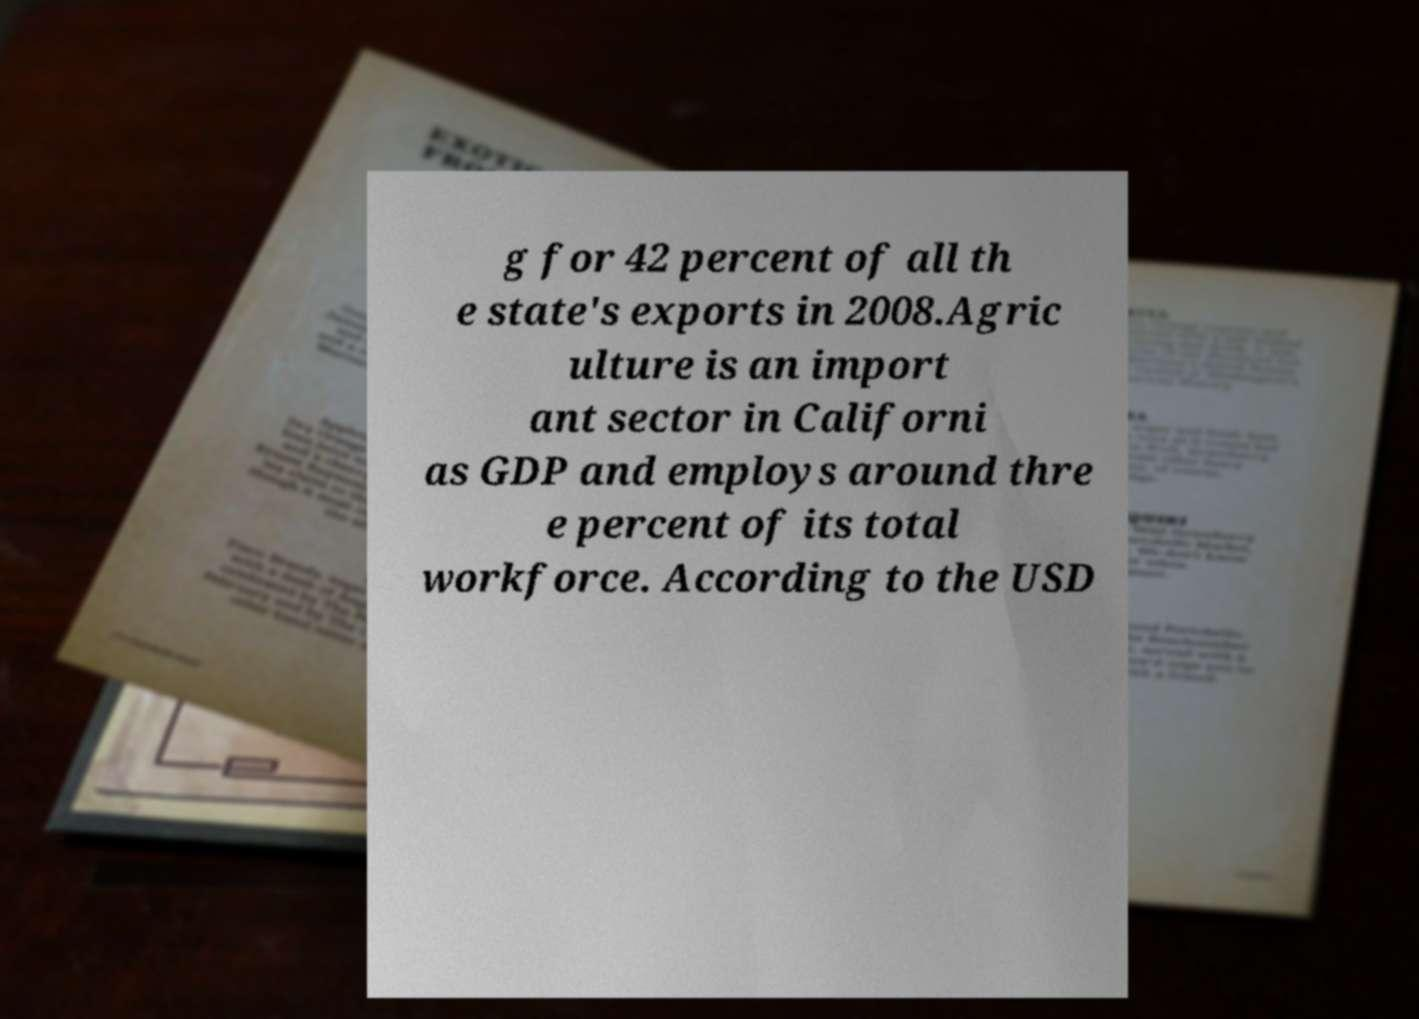What messages or text are displayed in this image? I need them in a readable, typed format. g for 42 percent of all th e state's exports in 2008.Agric ulture is an import ant sector in Californi as GDP and employs around thre e percent of its total workforce. According to the USD 